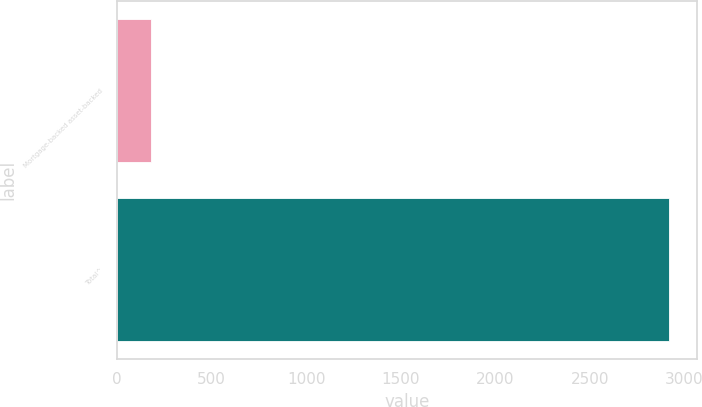Convert chart to OTSL. <chart><loc_0><loc_0><loc_500><loc_500><bar_chart><fcel>Mortgage-backed asset-backed<fcel>Total^<nl><fcel>181<fcel>2920<nl></chart> 